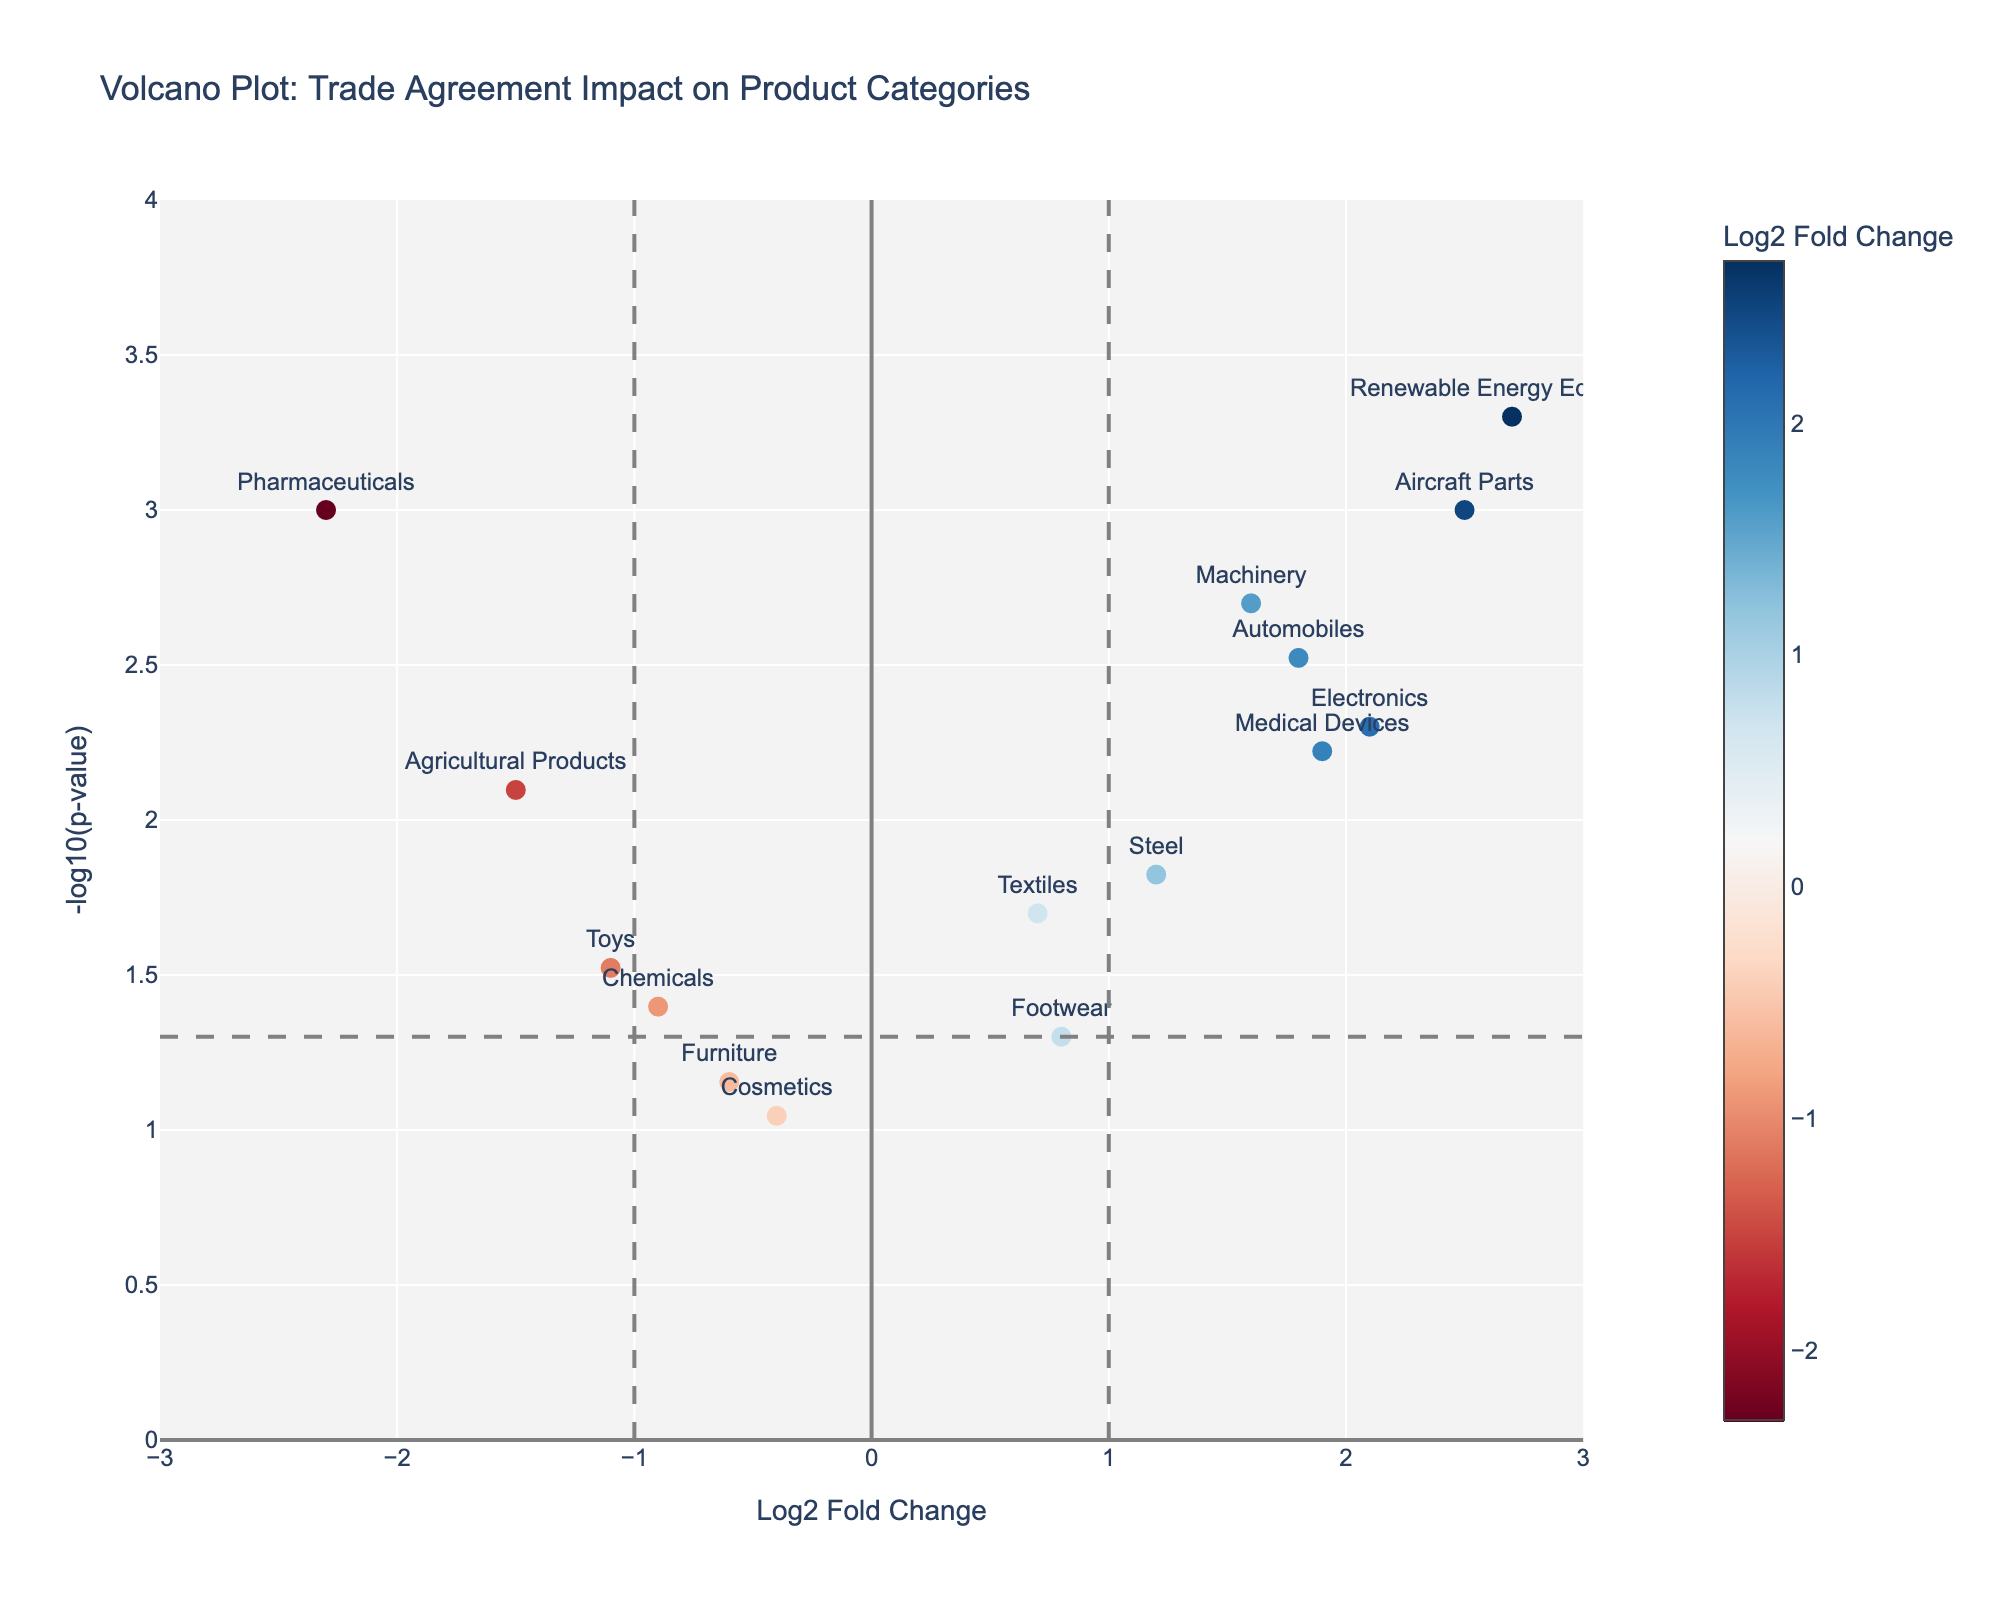What's the title of the plot? The title is usually displayed at the top of the plot. For this figure, it is clearly indicated.
Answer: Volcano Plot: Trade Agreement Impact on Product Categories What are the axis titles in the plot? The axis titles provide information about what each axis represents. The x-axis is labeled "Log2 Fold Change," and the y-axis is labeled "-log10(p-value)."
Answer: Log2 Fold Change (x-axis), -log10(p-value) (y-axis) How many product categories are shown in the plot? By counting the number of data points (markers), we can determine the number of product categories. There are 15 products in the dataset.
Answer: 15 Which product category has the highest Log2 Fold Change? By observing the x-axis, we see that the product category with the highest value on the right extreme is "Renewable Energy Equipment" with a Log2 Fold Change of 2.7.
Answer: Renewable Energy Equipment Which product category has the lowest Log2 Fold Change? By looking at the left extreme of the x-axis, we see that "Pharmaceuticals" has the lowest value with a Log2 Fold Change of -2.3.
Answer: Pharmaceuticals What threshold is marked by the horizontal dashed line in the plot? The horizontal dashed line corresponds to the p-value threshold of 0.05. The plotted line is at -log10(0.05), which equals approximately 1.3.
Answer: -log10(0.05), approximately 1.3 Which product categories show significant alterations in import/export volumes based on the plot? Products above the horizontal dashed line (p-value < 0.05) and have Log2 Fold Changes either greater than 1 or less than -1 are considered significant. They are Automobiles, Pharmaceuticals, Electronics, Agricultural Products, Machinery, Aircraft Parts, Medical Devices, and Renewable Energy Equipment.
Answer: Automobiles, Pharmaceuticals, Electronics, Agricultural Products, Machinery, Aircraft Parts, Medical Devices, and Renewable Energy Equipment Which product category has the most significant negative impact on import/export volumes? The product with the highest -log10(p-value) on the left side of the plot (negative Log2 Fold Change) is "Pharmaceuticals" with a p-value of 0.001.
Answer: Pharmaceuticals Based on the plot, which product categories had an increase in import/export volumes and were also statistically significant? Significant increases in volumes are indicated by data points to the right of x = 1 and above the horizontal line. These products are Automobiles, Electronics, Machinery, Aircraft Parts, Medical Devices, and Renewable Energy Equipment.
Answer: Automobiles, Electronics, Machinery, Aircraft Parts, Medical Devices, and Renewable Energy Equipment 